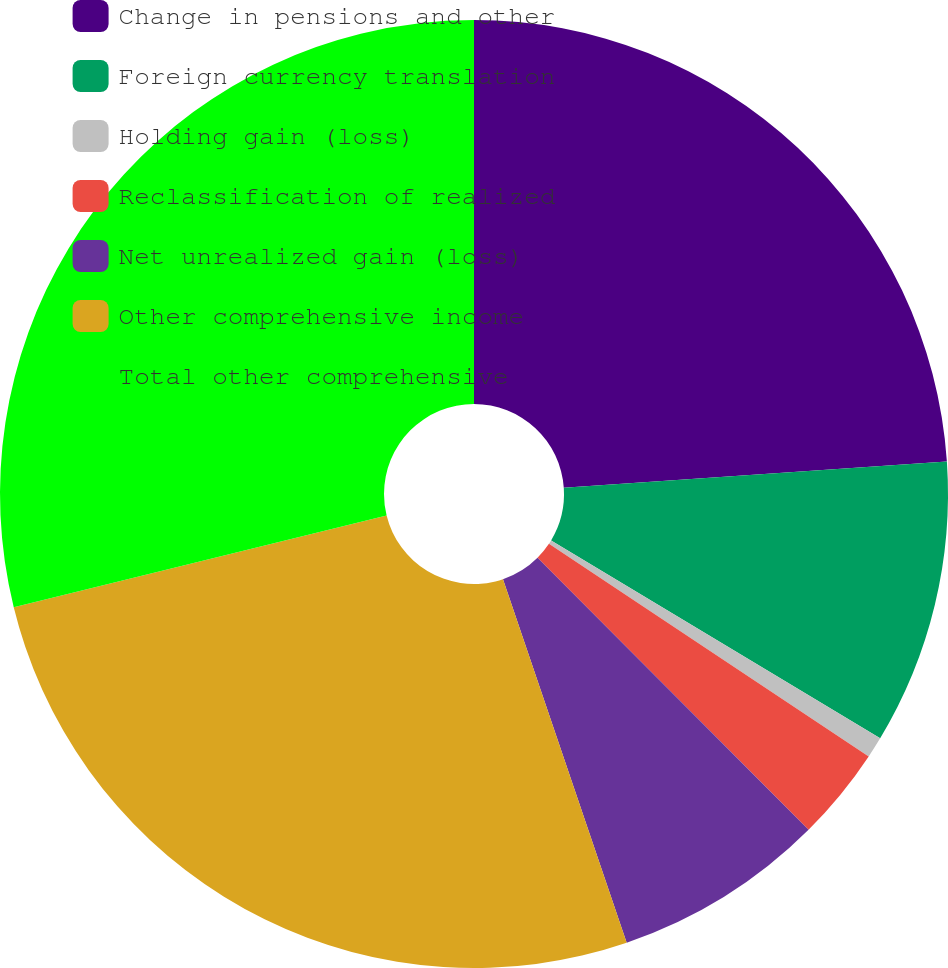Convert chart. <chart><loc_0><loc_0><loc_500><loc_500><pie_chart><fcel>Change in pensions and other<fcel>Foreign currency translation<fcel>Holding gain (loss)<fcel>Reclassification of realized<fcel>Net unrealized gain (loss)<fcel>Other comprehensive income<fcel>Total other comprehensive<nl><fcel>23.91%<fcel>9.71%<fcel>0.72%<fcel>3.19%<fcel>7.25%<fcel>26.38%<fcel>28.84%<nl></chart> 